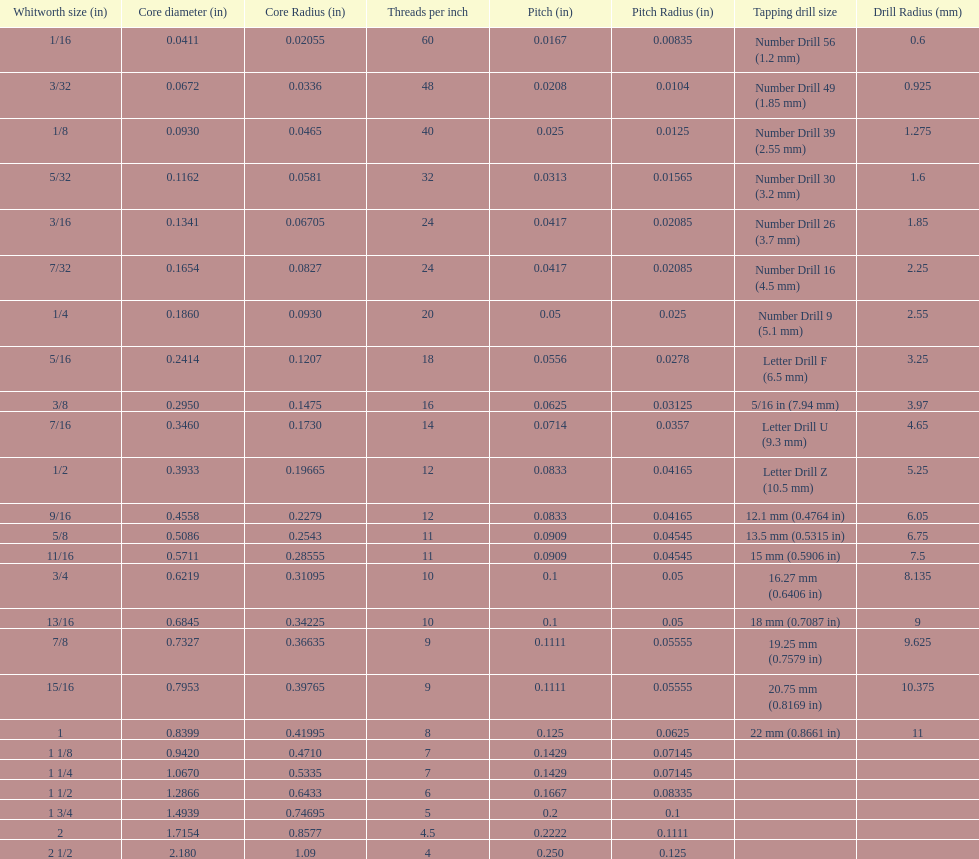How many threads per inch does a 9/16 have? 12. 